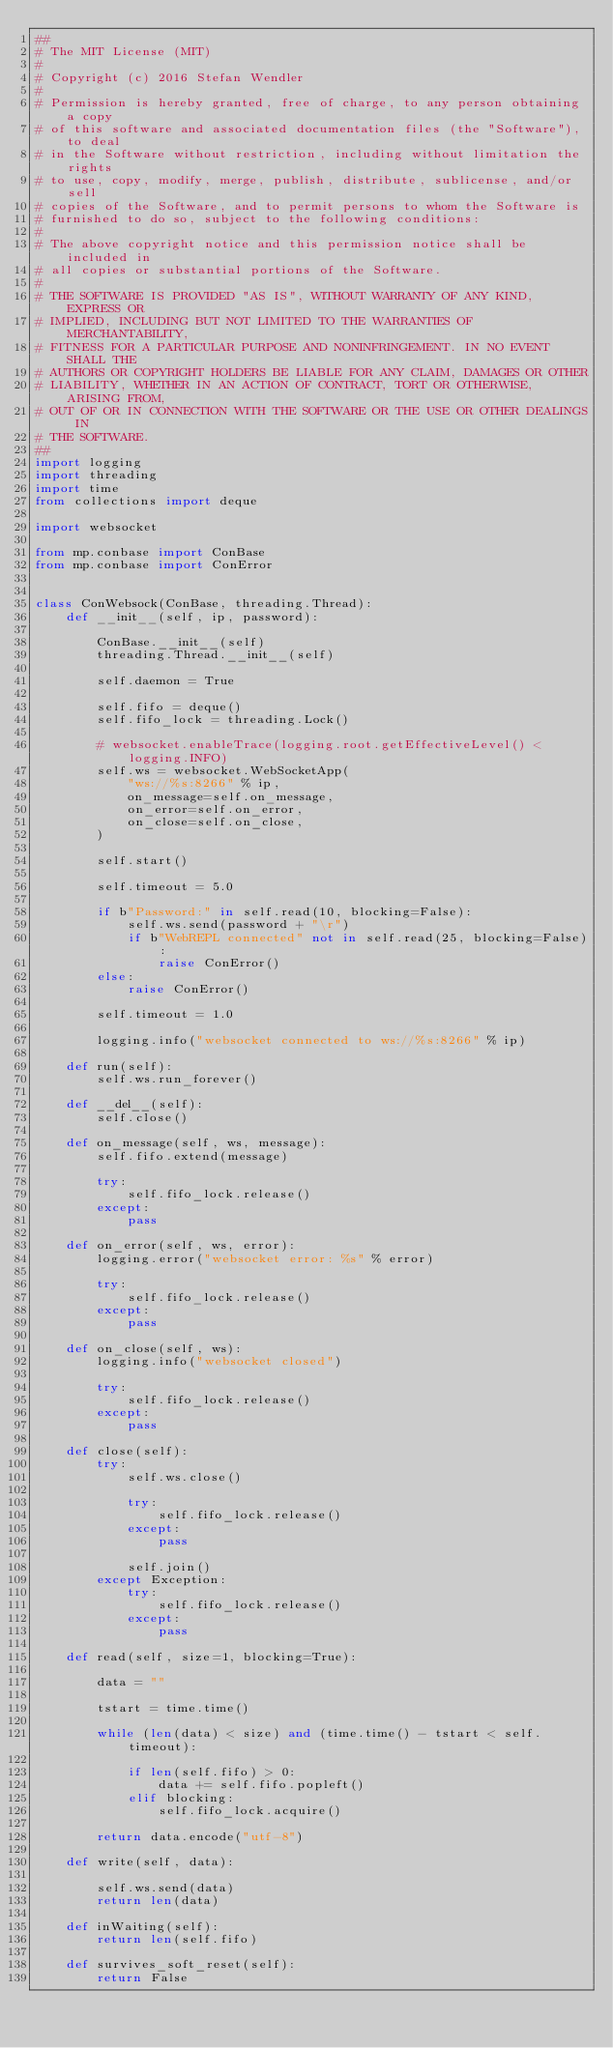<code> <loc_0><loc_0><loc_500><loc_500><_Python_>##
# The MIT License (MIT)
#
# Copyright (c) 2016 Stefan Wendler
#
# Permission is hereby granted, free of charge, to any person obtaining a copy
# of this software and associated documentation files (the "Software"), to deal
# in the Software without restriction, including without limitation the rights
# to use, copy, modify, merge, publish, distribute, sublicense, and/or sell
# copies of the Software, and to permit persons to whom the Software is
# furnished to do so, subject to the following conditions:
#
# The above copyright notice and this permission notice shall be included in
# all copies or substantial portions of the Software.
#
# THE SOFTWARE IS PROVIDED "AS IS", WITHOUT WARRANTY OF ANY KIND, EXPRESS OR
# IMPLIED, INCLUDING BUT NOT LIMITED TO THE WARRANTIES OF MERCHANTABILITY,
# FITNESS FOR A PARTICULAR PURPOSE AND NONINFRINGEMENT. IN NO EVENT SHALL THE
# AUTHORS OR COPYRIGHT HOLDERS BE LIABLE FOR ANY CLAIM, DAMAGES OR OTHER
# LIABILITY, WHETHER IN AN ACTION OF CONTRACT, TORT OR OTHERWISE, ARISING FROM,
# OUT OF OR IN CONNECTION WITH THE SOFTWARE OR THE USE OR OTHER DEALINGS IN
# THE SOFTWARE.
##
import logging
import threading
import time
from collections import deque

import websocket

from mp.conbase import ConBase
from mp.conbase import ConError


class ConWebsock(ConBase, threading.Thread):
    def __init__(self, ip, password):

        ConBase.__init__(self)
        threading.Thread.__init__(self)

        self.daemon = True

        self.fifo = deque()
        self.fifo_lock = threading.Lock()

        # websocket.enableTrace(logging.root.getEffectiveLevel() < logging.INFO)
        self.ws = websocket.WebSocketApp(
            "ws://%s:8266" % ip,
            on_message=self.on_message,
            on_error=self.on_error,
            on_close=self.on_close,
        )

        self.start()

        self.timeout = 5.0

        if b"Password:" in self.read(10, blocking=False):
            self.ws.send(password + "\r")
            if b"WebREPL connected" not in self.read(25, blocking=False):
                raise ConError()
        else:
            raise ConError()

        self.timeout = 1.0

        logging.info("websocket connected to ws://%s:8266" % ip)

    def run(self):
        self.ws.run_forever()

    def __del__(self):
        self.close()

    def on_message(self, ws, message):
        self.fifo.extend(message)

        try:
            self.fifo_lock.release()
        except:
            pass

    def on_error(self, ws, error):
        logging.error("websocket error: %s" % error)

        try:
            self.fifo_lock.release()
        except:
            pass

    def on_close(self, ws):
        logging.info("websocket closed")

        try:
            self.fifo_lock.release()
        except:
            pass

    def close(self):
        try:
            self.ws.close()

            try:
                self.fifo_lock.release()
            except:
                pass

            self.join()
        except Exception:
            try:
                self.fifo_lock.release()
            except:
                pass

    def read(self, size=1, blocking=True):

        data = ""

        tstart = time.time()

        while (len(data) < size) and (time.time() - tstart < self.timeout):

            if len(self.fifo) > 0:
                data += self.fifo.popleft()
            elif blocking:
                self.fifo_lock.acquire()

        return data.encode("utf-8")

    def write(self, data):

        self.ws.send(data)
        return len(data)

    def inWaiting(self):
        return len(self.fifo)

    def survives_soft_reset(self):
        return False
</code> 